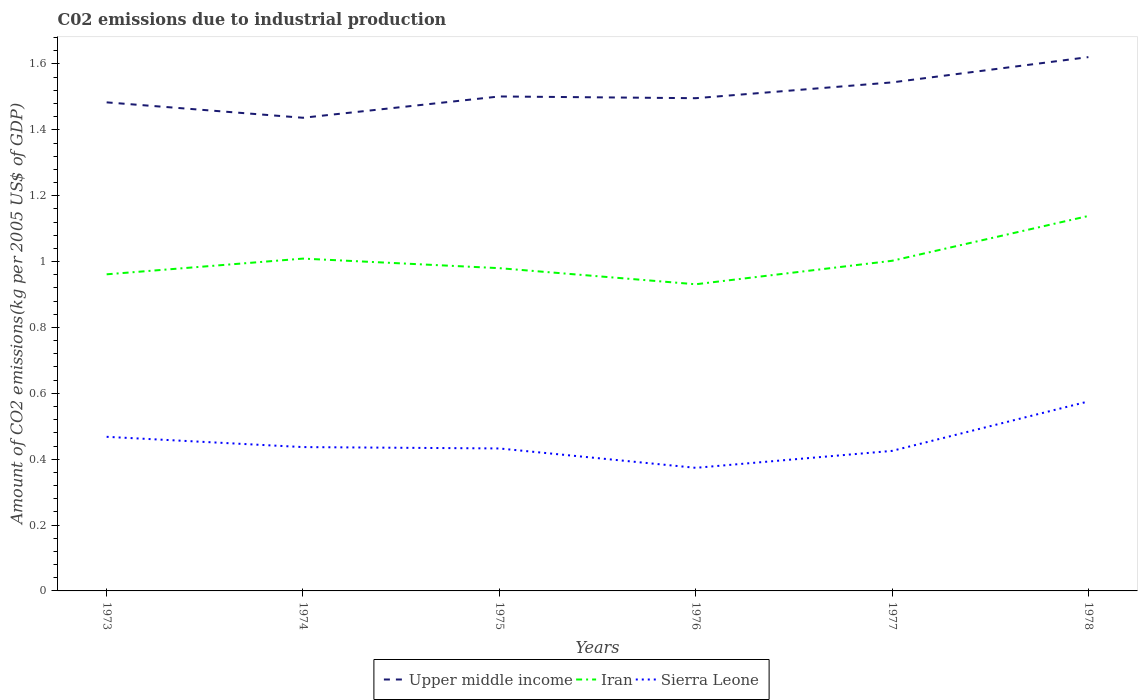Across all years, what is the maximum amount of CO2 emitted due to industrial production in Iran?
Offer a terse response. 0.93. In which year was the amount of CO2 emitted due to industrial production in Upper middle income maximum?
Make the answer very short. 1974. What is the total amount of CO2 emitted due to industrial production in Iran in the graph?
Offer a very short reply. -0.07. What is the difference between the highest and the second highest amount of CO2 emitted due to industrial production in Iran?
Offer a terse response. 0.21. What is the difference between the highest and the lowest amount of CO2 emitted due to industrial production in Iran?
Offer a very short reply. 2. What is the difference between two consecutive major ticks on the Y-axis?
Keep it short and to the point. 0.2. Are the values on the major ticks of Y-axis written in scientific E-notation?
Keep it short and to the point. No. Does the graph contain grids?
Give a very brief answer. No. What is the title of the graph?
Make the answer very short. C02 emissions due to industrial production. Does "Sub-Saharan Africa (all income levels)" appear as one of the legend labels in the graph?
Offer a terse response. No. What is the label or title of the Y-axis?
Offer a terse response. Amount of CO2 emissions(kg per 2005 US$ of GDP). What is the Amount of CO2 emissions(kg per 2005 US$ of GDP) in Upper middle income in 1973?
Offer a very short reply. 1.48. What is the Amount of CO2 emissions(kg per 2005 US$ of GDP) of Iran in 1973?
Ensure brevity in your answer.  0.96. What is the Amount of CO2 emissions(kg per 2005 US$ of GDP) in Sierra Leone in 1973?
Make the answer very short. 0.47. What is the Amount of CO2 emissions(kg per 2005 US$ of GDP) in Upper middle income in 1974?
Ensure brevity in your answer.  1.44. What is the Amount of CO2 emissions(kg per 2005 US$ of GDP) in Iran in 1974?
Offer a very short reply. 1.01. What is the Amount of CO2 emissions(kg per 2005 US$ of GDP) in Sierra Leone in 1974?
Your answer should be compact. 0.44. What is the Amount of CO2 emissions(kg per 2005 US$ of GDP) in Upper middle income in 1975?
Offer a terse response. 1.5. What is the Amount of CO2 emissions(kg per 2005 US$ of GDP) of Iran in 1975?
Make the answer very short. 0.98. What is the Amount of CO2 emissions(kg per 2005 US$ of GDP) in Sierra Leone in 1975?
Offer a terse response. 0.43. What is the Amount of CO2 emissions(kg per 2005 US$ of GDP) in Upper middle income in 1976?
Give a very brief answer. 1.5. What is the Amount of CO2 emissions(kg per 2005 US$ of GDP) in Iran in 1976?
Keep it short and to the point. 0.93. What is the Amount of CO2 emissions(kg per 2005 US$ of GDP) in Sierra Leone in 1976?
Keep it short and to the point. 0.37. What is the Amount of CO2 emissions(kg per 2005 US$ of GDP) in Upper middle income in 1977?
Keep it short and to the point. 1.54. What is the Amount of CO2 emissions(kg per 2005 US$ of GDP) of Iran in 1977?
Ensure brevity in your answer.  1. What is the Amount of CO2 emissions(kg per 2005 US$ of GDP) in Sierra Leone in 1977?
Provide a succinct answer. 0.43. What is the Amount of CO2 emissions(kg per 2005 US$ of GDP) in Upper middle income in 1978?
Ensure brevity in your answer.  1.62. What is the Amount of CO2 emissions(kg per 2005 US$ of GDP) in Iran in 1978?
Provide a short and direct response. 1.14. What is the Amount of CO2 emissions(kg per 2005 US$ of GDP) in Sierra Leone in 1978?
Your response must be concise. 0.58. Across all years, what is the maximum Amount of CO2 emissions(kg per 2005 US$ of GDP) of Upper middle income?
Provide a succinct answer. 1.62. Across all years, what is the maximum Amount of CO2 emissions(kg per 2005 US$ of GDP) of Iran?
Give a very brief answer. 1.14. Across all years, what is the maximum Amount of CO2 emissions(kg per 2005 US$ of GDP) in Sierra Leone?
Offer a terse response. 0.58. Across all years, what is the minimum Amount of CO2 emissions(kg per 2005 US$ of GDP) of Upper middle income?
Keep it short and to the point. 1.44. Across all years, what is the minimum Amount of CO2 emissions(kg per 2005 US$ of GDP) of Iran?
Provide a succinct answer. 0.93. Across all years, what is the minimum Amount of CO2 emissions(kg per 2005 US$ of GDP) in Sierra Leone?
Offer a very short reply. 0.37. What is the total Amount of CO2 emissions(kg per 2005 US$ of GDP) in Upper middle income in the graph?
Ensure brevity in your answer.  9.08. What is the total Amount of CO2 emissions(kg per 2005 US$ of GDP) in Iran in the graph?
Make the answer very short. 6.02. What is the total Amount of CO2 emissions(kg per 2005 US$ of GDP) of Sierra Leone in the graph?
Make the answer very short. 2.71. What is the difference between the Amount of CO2 emissions(kg per 2005 US$ of GDP) of Upper middle income in 1973 and that in 1974?
Offer a very short reply. 0.05. What is the difference between the Amount of CO2 emissions(kg per 2005 US$ of GDP) of Iran in 1973 and that in 1974?
Provide a succinct answer. -0.05. What is the difference between the Amount of CO2 emissions(kg per 2005 US$ of GDP) of Sierra Leone in 1973 and that in 1974?
Give a very brief answer. 0.03. What is the difference between the Amount of CO2 emissions(kg per 2005 US$ of GDP) in Upper middle income in 1973 and that in 1975?
Offer a very short reply. -0.02. What is the difference between the Amount of CO2 emissions(kg per 2005 US$ of GDP) in Iran in 1973 and that in 1975?
Your response must be concise. -0.02. What is the difference between the Amount of CO2 emissions(kg per 2005 US$ of GDP) of Sierra Leone in 1973 and that in 1975?
Make the answer very short. 0.04. What is the difference between the Amount of CO2 emissions(kg per 2005 US$ of GDP) in Upper middle income in 1973 and that in 1976?
Your response must be concise. -0.01. What is the difference between the Amount of CO2 emissions(kg per 2005 US$ of GDP) of Iran in 1973 and that in 1976?
Your answer should be very brief. 0.03. What is the difference between the Amount of CO2 emissions(kg per 2005 US$ of GDP) in Sierra Leone in 1973 and that in 1976?
Offer a terse response. 0.09. What is the difference between the Amount of CO2 emissions(kg per 2005 US$ of GDP) of Upper middle income in 1973 and that in 1977?
Your response must be concise. -0.06. What is the difference between the Amount of CO2 emissions(kg per 2005 US$ of GDP) of Iran in 1973 and that in 1977?
Ensure brevity in your answer.  -0.04. What is the difference between the Amount of CO2 emissions(kg per 2005 US$ of GDP) of Sierra Leone in 1973 and that in 1977?
Keep it short and to the point. 0.04. What is the difference between the Amount of CO2 emissions(kg per 2005 US$ of GDP) in Upper middle income in 1973 and that in 1978?
Offer a terse response. -0.14. What is the difference between the Amount of CO2 emissions(kg per 2005 US$ of GDP) in Iran in 1973 and that in 1978?
Provide a short and direct response. -0.18. What is the difference between the Amount of CO2 emissions(kg per 2005 US$ of GDP) of Sierra Leone in 1973 and that in 1978?
Make the answer very short. -0.11. What is the difference between the Amount of CO2 emissions(kg per 2005 US$ of GDP) of Upper middle income in 1974 and that in 1975?
Make the answer very short. -0.06. What is the difference between the Amount of CO2 emissions(kg per 2005 US$ of GDP) of Iran in 1974 and that in 1975?
Your answer should be very brief. 0.03. What is the difference between the Amount of CO2 emissions(kg per 2005 US$ of GDP) of Sierra Leone in 1974 and that in 1975?
Offer a very short reply. 0. What is the difference between the Amount of CO2 emissions(kg per 2005 US$ of GDP) of Upper middle income in 1974 and that in 1976?
Your answer should be compact. -0.06. What is the difference between the Amount of CO2 emissions(kg per 2005 US$ of GDP) of Iran in 1974 and that in 1976?
Ensure brevity in your answer.  0.08. What is the difference between the Amount of CO2 emissions(kg per 2005 US$ of GDP) in Sierra Leone in 1974 and that in 1976?
Make the answer very short. 0.06. What is the difference between the Amount of CO2 emissions(kg per 2005 US$ of GDP) in Upper middle income in 1974 and that in 1977?
Offer a very short reply. -0.11. What is the difference between the Amount of CO2 emissions(kg per 2005 US$ of GDP) of Iran in 1974 and that in 1977?
Offer a very short reply. 0.01. What is the difference between the Amount of CO2 emissions(kg per 2005 US$ of GDP) of Sierra Leone in 1974 and that in 1977?
Make the answer very short. 0.01. What is the difference between the Amount of CO2 emissions(kg per 2005 US$ of GDP) of Upper middle income in 1974 and that in 1978?
Keep it short and to the point. -0.18. What is the difference between the Amount of CO2 emissions(kg per 2005 US$ of GDP) in Iran in 1974 and that in 1978?
Make the answer very short. -0.13. What is the difference between the Amount of CO2 emissions(kg per 2005 US$ of GDP) of Sierra Leone in 1974 and that in 1978?
Keep it short and to the point. -0.14. What is the difference between the Amount of CO2 emissions(kg per 2005 US$ of GDP) in Upper middle income in 1975 and that in 1976?
Offer a very short reply. 0.01. What is the difference between the Amount of CO2 emissions(kg per 2005 US$ of GDP) in Iran in 1975 and that in 1976?
Ensure brevity in your answer.  0.05. What is the difference between the Amount of CO2 emissions(kg per 2005 US$ of GDP) in Sierra Leone in 1975 and that in 1976?
Give a very brief answer. 0.06. What is the difference between the Amount of CO2 emissions(kg per 2005 US$ of GDP) in Upper middle income in 1975 and that in 1977?
Your answer should be compact. -0.04. What is the difference between the Amount of CO2 emissions(kg per 2005 US$ of GDP) in Iran in 1975 and that in 1977?
Your response must be concise. -0.02. What is the difference between the Amount of CO2 emissions(kg per 2005 US$ of GDP) in Sierra Leone in 1975 and that in 1977?
Make the answer very short. 0.01. What is the difference between the Amount of CO2 emissions(kg per 2005 US$ of GDP) in Upper middle income in 1975 and that in 1978?
Ensure brevity in your answer.  -0.12. What is the difference between the Amount of CO2 emissions(kg per 2005 US$ of GDP) in Iran in 1975 and that in 1978?
Your answer should be very brief. -0.16. What is the difference between the Amount of CO2 emissions(kg per 2005 US$ of GDP) of Sierra Leone in 1975 and that in 1978?
Make the answer very short. -0.14. What is the difference between the Amount of CO2 emissions(kg per 2005 US$ of GDP) in Upper middle income in 1976 and that in 1977?
Ensure brevity in your answer.  -0.05. What is the difference between the Amount of CO2 emissions(kg per 2005 US$ of GDP) in Iran in 1976 and that in 1977?
Give a very brief answer. -0.07. What is the difference between the Amount of CO2 emissions(kg per 2005 US$ of GDP) in Sierra Leone in 1976 and that in 1977?
Give a very brief answer. -0.05. What is the difference between the Amount of CO2 emissions(kg per 2005 US$ of GDP) in Upper middle income in 1976 and that in 1978?
Make the answer very short. -0.12. What is the difference between the Amount of CO2 emissions(kg per 2005 US$ of GDP) in Iran in 1976 and that in 1978?
Your answer should be very brief. -0.21. What is the difference between the Amount of CO2 emissions(kg per 2005 US$ of GDP) in Sierra Leone in 1976 and that in 1978?
Your answer should be very brief. -0.2. What is the difference between the Amount of CO2 emissions(kg per 2005 US$ of GDP) of Upper middle income in 1977 and that in 1978?
Your answer should be compact. -0.08. What is the difference between the Amount of CO2 emissions(kg per 2005 US$ of GDP) of Iran in 1977 and that in 1978?
Make the answer very short. -0.14. What is the difference between the Amount of CO2 emissions(kg per 2005 US$ of GDP) in Sierra Leone in 1977 and that in 1978?
Offer a very short reply. -0.15. What is the difference between the Amount of CO2 emissions(kg per 2005 US$ of GDP) in Upper middle income in 1973 and the Amount of CO2 emissions(kg per 2005 US$ of GDP) in Iran in 1974?
Your answer should be compact. 0.47. What is the difference between the Amount of CO2 emissions(kg per 2005 US$ of GDP) of Upper middle income in 1973 and the Amount of CO2 emissions(kg per 2005 US$ of GDP) of Sierra Leone in 1974?
Provide a succinct answer. 1.05. What is the difference between the Amount of CO2 emissions(kg per 2005 US$ of GDP) in Iran in 1973 and the Amount of CO2 emissions(kg per 2005 US$ of GDP) in Sierra Leone in 1974?
Your answer should be compact. 0.52. What is the difference between the Amount of CO2 emissions(kg per 2005 US$ of GDP) of Upper middle income in 1973 and the Amount of CO2 emissions(kg per 2005 US$ of GDP) of Iran in 1975?
Offer a very short reply. 0.5. What is the difference between the Amount of CO2 emissions(kg per 2005 US$ of GDP) of Upper middle income in 1973 and the Amount of CO2 emissions(kg per 2005 US$ of GDP) of Sierra Leone in 1975?
Make the answer very short. 1.05. What is the difference between the Amount of CO2 emissions(kg per 2005 US$ of GDP) of Iran in 1973 and the Amount of CO2 emissions(kg per 2005 US$ of GDP) of Sierra Leone in 1975?
Your answer should be very brief. 0.53. What is the difference between the Amount of CO2 emissions(kg per 2005 US$ of GDP) of Upper middle income in 1973 and the Amount of CO2 emissions(kg per 2005 US$ of GDP) of Iran in 1976?
Your answer should be compact. 0.55. What is the difference between the Amount of CO2 emissions(kg per 2005 US$ of GDP) of Upper middle income in 1973 and the Amount of CO2 emissions(kg per 2005 US$ of GDP) of Sierra Leone in 1976?
Keep it short and to the point. 1.11. What is the difference between the Amount of CO2 emissions(kg per 2005 US$ of GDP) in Iran in 1973 and the Amount of CO2 emissions(kg per 2005 US$ of GDP) in Sierra Leone in 1976?
Keep it short and to the point. 0.59. What is the difference between the Amount of CO2 emissions(kg per 2005 US$ of GDP) in Upper middle income in 1973 and the Amount of CO2 emissions(kg per 2005 US$ of GDP) in Iran in 1977?
Make the answer very short. 0.48. What is the difference between the Amount of CO2 emissions(kg per 2005 US$ of GDP) of Upper middle income in 1973 and the Amount of CO2 emissions(kg per 2005 US$ of GDP) of Sierra Leone in 1977?
Provide a succinct answer. 1.06. What is the difference between the Amount of CO2 emissions(kg per 2005 US$ of GDP) in Iran in 1973 and the Amount of CO2 emissions(kg per 2005 US$ of GDP) in Sierra Leone in 1977?
Provide a short and direct response. 0.54. What is the difference between the Amount of CO2 emissions(kg per 2005 US$ of GDP) in Upper middle income in 1973 and the Amount of CO2 emissions(kg per 2005 US$ of GDP) in Iran in 1978?
Make the answer very short. 0.34. What is the difference between the Amount of CO2 emissions(kg per 2005 US$ of GDP) of Upper middle income in 1973 and the Amount of CO2 emissions(kg per 2005 US$ of GDP) of Sierra Leone in 1978?
Ensure brevity in your answer.  0.91. What is the difference between the Amount of CO2 emissions(kg per 2005 US$ of GDP) in Iran in 1973 and the Amount of CO2 emissions(kg per 2005 US$ of GDP) in Sierra Leone in 1978?
Provide a succinct answer. 0.39. What is the difference between the Amount of CO2 emissions(kg per 2005 US$ of GDP) in Upper middle income in 1974 and the Amount of CO2 emissions(kg per 2005 US$ of GDP) in Iran in 1975?
Give a very brief answer. 0.46. What is the difference between the Amount of CO2 emissions(kg per 2005 US$ of GDP) in Upper middle income in 1974 and the Amount of CO2 emissions(kg per 2005 US$ of GDP) in Sierra Leone in 1975?
Your answer should be very brief. 1. What is the difference between the Amount of CO2 emissions(kg per 2005 US$ of GDP) of Iran in 1974 and the Amount of CO2 emissions(kg per 2005 US$ of GDP) of Sierra Leone in 1975?
Your answer should be very brief. 0.58. What is the difference between the Amount of CO2 emissions(kg per 2005 US$ of GDP) in Upper middle income in 1974 and the Amount of CO2 emissions(kg per 2005 US$ of GDP) in Iran in 1976?
Give a very brief answer. 0.51. What is the difference between the Amount of CO2 emissions(kg per 2005 US$ of GDP) in Upper middle income in 1974 and the Amount of CO2 emissions(kg per 2005 US$ of GDP) in Sierra Leone in 1976?
Offer a very short reply. 1.06. What is the difference between the Amount of CO2 emissions(kg per 2005 US$ of GDP) of Iran in 1974 and the Amount of CO2 emissions(kg per 2005 US$ of GDP) of Sierra Leone in 1976?
Ensure brevity in your answer.  0.64. What is the difference between the Amount of CO2 emissions(kg per 2005 US$ of GDP) of Upper middle income in 1974 and the Amount of CO2 emissions(kg per 2005 US$ of GDP) of Iran in 1977?
Provide a succinct answer. 0.43. What is the difference between the Amount of CO2 emissions(kg per 2005 US$ of GDP) of Upper middle income in 1974 and the Amount of CO2 emissions(kg per 2005 US$ of GDP) of Sierra Leone in 1977?
Your answer should be very brief. 1.01. What is the difference between the Amount of CO2 emissions(kg per 2005 US$ of GDP) in Iran in 1974 and the Amount of CO2 emissions(kg per 2005 US$ of GDP) in Sierra Leone in 1977?
Offer a terse response. 0.58. What is the difference between the Amount of CO2 emissions(kg per 2005 US$ of GDP) in Upper middle income in 1974 and the Amount of CO2 emissions(kg per 2005 US$ of GDP) in Iran in 1978?
Provide a short and direct response. 0.3. What is the difference between the Amount of CO2 emissions(kg per 2005 US$ of GDP) of Upper middle income in 1974 and the Amount of CO2 emissions(kg per 2005 US$ of GDP) of Sierra Leone in 1978?
Provide a succinct answer. 0.86. What is the difference between the Amount of CO2 emissions(kg per 2005 US$ of GDP) of Iran in 1974 and the Amount of CO2 emissions(kg per 2005 US$ of GDP) of Sierra Leone in 1978?
Your answer should be compact. 0.43. What is the difference between the Amount of CO2 emissions(kg per 2005 US$ of GDP) of Upper middle income in 1975 and the Amount of CO2 emissions(kg per 2005 US$ of GDP) of Iran in 1976?
Provide a succinct answer. 0.57. What is the difference between the Amount of CO2 emissions(kg per 2005 US$ of GDP) in Upper middle income in 1975 and the Amount of CO2 emissions(kg per 2005 US$ of GDP) in Sierra Leone in 1976?
Offer a terse response. 1.13. What is the difference between the Amount of CO2 emissions(kg per 2005 US$ of GDP) in Iran in 1975 and the Amount of CO2 emissions(kg per 2005 US$ of GDP) in Sierra Leone in 1976?
Provide a short and direct response. 0.61. What is the difference between the Amount of CO2 emissions(kg per 2005 US$ of GDP) of Upper middle income in 1975 and the Amount of CO2 emissions(kg per 2005 US$ of GDP) of Iran in 1977?
Provide a succinct answer. 0.5. What is the difference between the Amount of CO2 emissions(kg per 2005 US$ of GDP) in Upper middle income in 1975 and the Amount of CO2 emissions(kg per 2005 US$ of GDP) in Sierra Leone in 1977?
Your response must be concise. 1.08. What is the difference between the Amount of CO2 emissions(kg per 2005 US$ of GDP) of Iran in 1975 and the Amount of CO2 emissions(kg per 2005 US$ of GDP) of Sierra Leone in 1977?
Offer a very short reply. 0.55. What is the difference between the Amount of CO2 emissions(kg per 2005 US$ of GDP) in Upper middle income in 1975 and the Amount of CO2 emissions(kg per 2005 US$ of GDP) in Iran in 1978?
Provide a succinct answer. 0.36. What is the difference between the Amount of CO2 emissions(kg per 2005 US$ of GDP) of Upper middle income in 1975 and the Amount of CO2 emissions(kg per 2005 US$ of GDP) of Sierra Leone in 1978?
Your answer should be very brief. 0.93. What is the difference between the Amount of CO2 emissions(kg per 2005 US$ of GDP) of Iran in 1975 and the Amount of CO2 emissions(kg per 2005 US$ of GDP) of Sierra Leone in 1978?
Offer a very short reply. 0.4. What is the difference between the Amount of CO2 emissions(kg per 2005 US$ of GDP) in Upper middle income in 1976 and the Amount of CO2 emissions(kg per 2005 US$ of GDP) in Iran in 1977?
Your answer should be very brief. 0.49. What is the difference between the Amount of CO2 emissions(kg per 2005 US$ of GDP) of Upper middle income in 1976 and the Amount of CO2 emissions(kg per 2005 US$ of GDP) of Sierra Leone in 1977?
Your answer should be very brief. 1.07. What is the difference between the Amount of CO2 emissions(kg per 2005 US$ of GDP) of Iran in 1976 and the Amount of CO2 emissions(kg per 2005 US$ of GDP) of Sierra Leone in 1977?
Provide a short and direct response. 0.51. What is the difference between the Amount of CO2 emissions(kg per 2005 US$ of GDP) in Upper middle income in 1976 and the Amount of CO2 emissions(kg per 2005 US$ of GDP) in Iran in 1978?
Make the answer very short. 0.36. What is the difference between the Amount of CO2 emissions(kg per 2005 US$ of GDP) in Upper middle income in 1976 and the Amount of CO2 emissions(kg per 2005 US$ of GDP) in Sierra Leone in 1978?
Offer a terse response. 0.92. What is the difference between the Amount of CO2 emissions(kg per 2005 US$ of GDP) of Iran in 1976 and the Amount of CO2 emissions(kg per 2005 US$ of GDP) of Sierra Leone in 1978?
Offer a very short reply. 0.36. What is the difference between the Amount of CO2 emissions(kg per 2005 US$ of GDP) in Upper middle income in 1977 and the Amount of CO2 emissions(kg per 2005 US$ of GDP) in Iran in 1978?
Ensure brevity in your answer.  0.41. What is the difference between the Amount of CO2 emissions(kg per 2005 US$ of GDP) in Upper middle income in 1977 and the Amount of CO2 emissions(kg per 2005 US$ of GDP) in Sierra Leone in 1978?
Offer a terse response. 0.97. What is the difference between the Amount of CO2 emissions(kg per 2005 US$ of GDP) of Iran in 1977 and the Amount of CO2 emissions(kg per 2005 US$ of GDP) of Sierra Leone in 1978?
Provide a succinct answer. 0.43. What is the average Amount of CO2 emissions(kg per 2005 US$ of GDP) in Upper middle income per year?
Offer a terse response. 1.51. What is the average Amount of CO2 emissions(kg per 2005 US$ of GDP) of Sierra Leone per year?
Ensure brevity in your answer.  0.45. In the year 1973, what is the difference between the Amount of CO2 emissions(kg per 2005 US$ of GDP) of Upper middle income and Amount of CO2 emissions(kg per 2005 US$ of GDP) of Iran?
Ensure brevity in your answer.  0.52. In the year 1973, what is the difference between the Amount of CO2 emissions(kg per 2005 US$ of GDP) in Upper middle income and Amount of CO2 emissions(kg per 2005 US$ of GDP) in Sierra Leone?
Make the answer very short. 1.02. In the year 1973, what is the difference between the Amount of CO2 emissions(kg per 2005 US$ of GDP) in Iran and Amount of CO2 emissions(kg per 2005 US$ of GDP) in Sierra Leone?
Keep it short and to the point. 0.49. In the year 1974, what is the difference between the Amount of CO2 emissions(kg per 2005 US$ of GDP) in Upper middle income and Amount of CO2 emissions(kg per 2005 US$ of GDP) in Iran?
Ensure brevity in your answer.  0.43. In the year 1974, what is the difference between the Amount of CO2 emissions(kg per 2005 US$ of GDP) of Iran and Amount of CO2 emissions(kg per 2005 US$ of GDP) of Sierra Leone?
Ensure brevity in your answer.  0.57. In the year 1975, what is the difference between the Amount of CO2 emissions(kg per 2005 US$ of GDP) in Upper middle income and Amount of CO2 emissions(kg per 2005 US$ of GDP) in Iran?
Your answer should be compact. 0.52. In the year 1975, what is the difference between the Amount of CO2 emissions(kg per 2005 US$ of GDP) in Upper middle income and Amount of CO2 emissions(kg per 2005 US$ of GDP) in Sierra Leone?
Your answer should be very brief. 1.07. In the year 1975, what is the difference between the Amount of CO2 emissions(kg per 2005 US$ of GDP) of Iran and Amount of CO2 emissions(kg per 2005 US$ of GDP) of Sierra Leone?
Keep it short and to the point. 0.55. In the year 1976, what is the difference between the Amount of CO2 emissions(kg per 2005 US$ of GDP) in Upper middle income and Amount of CO2 emissions(kg per 2005 US$ of GDP) in Iran?
Keep it short and to the point. 0.56. In the year 1976, what is the difference between the Amount of CO2 emissions(kg per 2005 US$ of GDP) of Upper middle income and Amount of CO2 emissions(kg per 2005 US$ of GDP) of Sierra Leone?
Provide a succinct answer. 1.12. In the year 1976, what is the difference between the Amount of CO2 emissions(kg per 2005 US$ of GDP) in Iran and Amount of CO2 emissions(kg per 2005 US$ of GDP) in Sierra Leone?
Your answer should be very brief. 0.56. In the year 1977, what is the difference between the Amount of CO2 emissions(kg per 2005 US$ of GDP) in Upper middle income and Amount of CO2 emissions(kg per 2005 US$ of GDP) in Iran?
Offer a very short reply. 0.54. In the year 1977, what is the difference between the Amount of CO2 emissions(kg per 2005 US$ of GDP) of Upper middle income and Amount of CO2 emissions(kg per 2005 US$ of GDP) of Sierra Leone?
Make the answer very short. 1.12. In the year 1977, what is the difference between the Amount of CO2 emissions(kg per 2005 US$ of GDP) in Iran and Amount of CO2 emissions(kg per 2005 US$ of GDP) in Sierra Leone?
Ensure brevity in your answer.  0.58. In the year 1978, what is the difference between the Amount of CO2 emissions(kg per 2005 US$ of GDP) in Upper middle income and Amount of CO2 emissions(kg per 2005 US$ of GDP) in Iran?
Give a very brief answer. 0.48. In the year 1978, what is the difference between the Amount of CO2 emissions(kg per 2005 US$ of GDP) in Upper middle income and Amount of CO2 emissions(kg per 2005 US$ of GDP) in Sierra Leone?
Your answer should be very brief. 1.05. In the year 1978, what is the difference between the Amount of CO2 emissions(kg per 2005 US$ of GDP) in Iran and Amount of CO2 emissions(kg per 2005 US$ of GDP) in Sierra Leone?
Offer a very short reply. 0.56. What is the ratio of the Amount of CO2 emissions(kg per 2005 US$ of GDP) in Upper middle income in 1973 to that in 1974?
Your answer should be very brief. 1.03. What is the ratio of the Amount of CO2 emissions(kg per 2005 US$ of GDP) of Iran in 1973 to that in 1974?
Give a very brief answer. 0.95. What is the ratio of the Amount of CO2 emissions(kg per 2005 US$ of GDP) in Sierra Leone in 1973 to that in 1974?
Your response must be concise. 1.07. What is the ratio of the Amount of CO2 emissions(kg per 2005 US$ of GDP) of Iran in 1973 to that in 1975?
Your response must be concise. 0.98. What is the ratio of the Amount of CO2 emissions(kg per 2005 US$ of GDP) in Sierra Leone in 1973 to that in 1975?
Your response must be concise. 1.08. What is the ratio of the Amount of CO2 emissions(kg per 2005 US$ of GDP) in Iran in 1973 to that in 1976?
Your response must be concise. 1.03. What is the ratio of the Amount of CO2 emissions(kg per 2005 US$ of GDP) of Sierra Leone in 1973 to that in 1976?
Keep it short and to the point. 1.25. What is the ratio of the Amount of CO2 emissions(kg per 2005 US$ of GDP) of Upper middle income in 1973 to that in 1977?
Keep it short and to the point. 0.96. What is the ratio of the Amount of CO2 emissions(kg per 2005 US$ of GDP) in Iran in 1973 to that in 1977?
Provide a succinct answer. 0.96. What is the ratio of the Amount of CO2 emissions(kg per 2005 US$ of GDP) of Sierra Leone in 1973 to that in 1977?
Offer a terse response. 1.1. What is the ratio of the Amount of CO2 emissions(kg per 2005 US$ of GDP) in Upper middle income in 1973 to that in 1978?
Provide a succinct answer. 0.92. What is the ratio of the Amount of CO2 emissions(kg per 2005 US$ of GDP) of Iran in 1973 to that in 1978?
Your response must be concise. 0.84. What is the ratio of the Amount of CO2 emissions(kg per 2005 US$ of GDP) in Sierra Leone in 1973 to that in 1978?
Your answer should be very brief. 0.81. What is the ratio of the Amount of CO2 emissions(kg per 2005 US$ of GDP) in Upper middle income in 1974 to that in 1975?
Keep it short and to the point. 0.96. What is the ratio of the Amount of CO2 emissions(kg per 2005 US$ of GDP) of Iran in 1974 to that in 1975?
Offer a terse response. 1.03. What is the ratio of the Amount of CO2 emissions(kg per 2005 US$ of GDP) of Sierra Leone in 1974 to that in 1975?
Your response must be concise. 1.01. What is the ratio of the Amount of CO2 emissions(kg per 2005 US$ of GDP) of Upper middle income in 1974 to that in 1976?
Give a very brief answer. 0.96. What is the ratio of the Amount of CO2 emissions(kg per 2005 US$ of GDP) of Iran in 1974 to that in 1976?
Offer a very short reply. 1.08. What is the ratio of the Amount of CO2 emissions(kg per 2005 US$ of GDP) in Sierra Leone in 1974 to that in 1976?
Offer a terse response. 1.17. What is the ratio of the Amount of CO2 emissions(kg per 2005 US$ of GDP) of Upper middle income in 1974 to that in 1977?
Offer a very short reply. 0.93. What is the ratio of the Amount of CO2 emissions(kg per 2005 US$ of GDP) of Iran in 1974 to that in 1977?
Your answer should be compact. 1.01. What is the ratio of the Amount of CO2 emissions(kg per 2005 US$ of GDP) in Sierra Leone in 1974 to that in 1977?
Your response must be concise. 1.03. What is the ratio of the Amount of CO2 emissions(kg per 2005 US$ of GDP) in Upper middle income in 1974 to that in 1978?
Offer a terse response. 0.89. What is the ratio of the Amount of CO2 emissions(kg per 2005 US$ of GDP) of Iran in 1974 to that in 1978?
Offer a terse response. 0.89. What is the ratio of the Amount of CO2 emissions(kg per 2005 US$ of GDP) of Sierra Leone in 1974 to that in 1978?
Your answer should be very brief. 0.76. What is the ratio of the Amount of CO2 emissions(kg per 2005 US$ of GDP) in Upper middle income in 1975 to that in 1976?
Provide a succinct answer. 1. What is the ratio of the Amount of CO2 emissions(kg per 2005 US$ of GDP) of Iran in 1975 to that in 1976?
Give a very brief answer. 1.05. What is the ratio of the Amount of CO2 emissions(kg per 2005 US$ of GDP) in Sierra Leone in 1975 to that in 1976?
Your answer should be compact. 1.16. What is the ratio of the Amount of CO2 emissions(kg per 2005 US$ of GDP) in Upper middle income in 1975 to that in 1977?
Your response must be concise. 0.97. What is the ratio of the Amount of CO2 emissions(kg per 2005 US$ of GDP) in Iran in 1975 to that in 1977?
Give a very brief answer. 0.98. What is the ratio of the Amount of CO2 emissions(kg per 2005 US$ of GDP) in Sierra Leone in 1975 to that in 1977?
Ensure brevity in your answer.  1.02. What is the ratio of the Amount of CO2 emissions(kg per 2005 US$ of GDP) in Upper middle income in 1975 to that in 1978?
Keep it short and to the point. 0.93. What is the ratio of the Amount of CO2 emissions(kg per 2005 US$ of GDP) in Iran in 1975 to that in 1978?
Make the answer very short. 0.86. What is the ratio of the Amount of CO2 emissions(kg per 2005 US$ of GDP) of Sierra Leone in 1975 to that in 1978?
Your answer should be compact. 0.75. What is the ratio of the Amount of CO2 emissions(kg per 2005 US$ of GDP) of Upper middle income in 1976 to that in 1977?
Your response must be concise. 0.97. What is the ratio of the Amount of CO2 emissions(kg per 2005 US$ of GDP) in Iran in 1976 to that in 1977?
Provide a succinct answer. 0.93. What is the ratio of the Amount of CO2 emissions(kg per 2005 US$ of GDP) in Sierra Leone in 1976 to that in 1977?
Ensure brevity in your answer.  0.88. What is the ratio of the Amount of CO2 emissions(kg per 2005 US$ of GDP) of Upper middle income in 1976 to that in 1978?
Your answer should be very brief. 0.92. What is the ratio of the Amount of CO2 emissions(kg per 2005 US$ of GDP) of Iran in 1976 to that in 1978?
Make the answer very short. 0.82. What is the ratio of the Amount of CO2 emissions(kg per 2005 US$ of GDP) of Sierra Leone in 1976 to that in 1978?
Offer a terse response. 0.65. What is the ratio of the Amount of CO2 emissions(kg per 2005 US$ of GDP) of Upper middle income in 1977 to that in 1978?
Your response must be concise. 0.95. What is the ratio of the Amount of CO2 emissions(kg per 2005 US$ of GDP) in Iran in 1977 to that in 1978?
Your response must be concise. 0.88. What is the ratio of the Amount of CO2 emissions(kg per 2005 US$ of GDP) of Sierra Leone in 1977 to that in 1978?
Your response must be concise. 0.74. What is the difference between the highest and the second highest Amount of CO2 emissions(kg per 2005 US$ of GDP) of Upper middle income?
Your answer should be very brief. 0.08. What is the difference between the highest and the second highest Amount of CO2 emissions(kg per 2005 US$ of GDP) in Iran?
Offer a terse response. 0.13. What is the difference between the highest and the second highest Amount of CO2 emissions(kg per 2005 US$ of GDP) of Sierra Leone?
Provide a succinct answer. 0.11. What is the difference between the highest and the lowest Amount of CO2 emissions(kg per 2005 US$ of GDP) of Upper middle income?
Offer a very short reply. 0.18. What is the difference between the highest and the lowest Amount of CO2 emissions(kg per 2005 US$ of GDP) in Iran?
Keep it short and to the point. 0.21. What is the difference between the highest and the lowest Amount of CO2 emissions(kg per 2005 US$ of GDP) in Sierra Leone?
Make the answer very short. 0.2. 